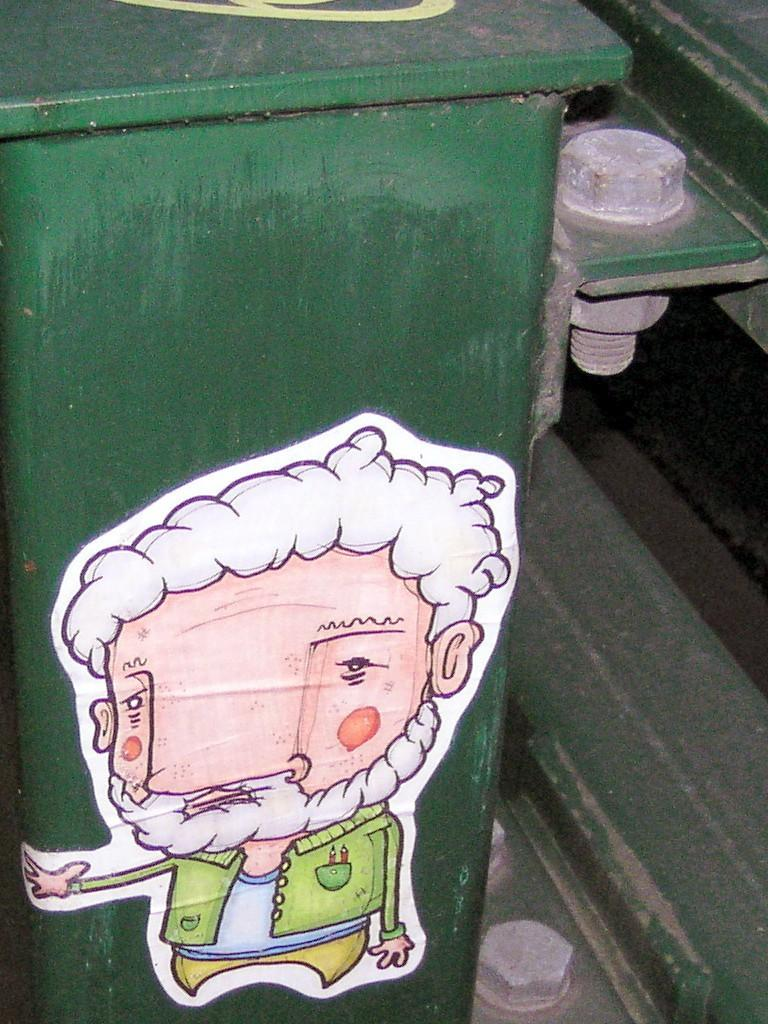What color is the table in the image? The table in the image is green. What is on the table in the image? There is a sticker placed on the table. What can be seen on the right side of the image? There are iron bolts on the right side of the image. What color is the background of the image? The background of the image is green. What type of button is on the table in the image? There is no button present on the table in the image. What letters can be seen on the sticker in the image? There is no information about letters on the sticker in the provided facts, so we cannot answer this question. 